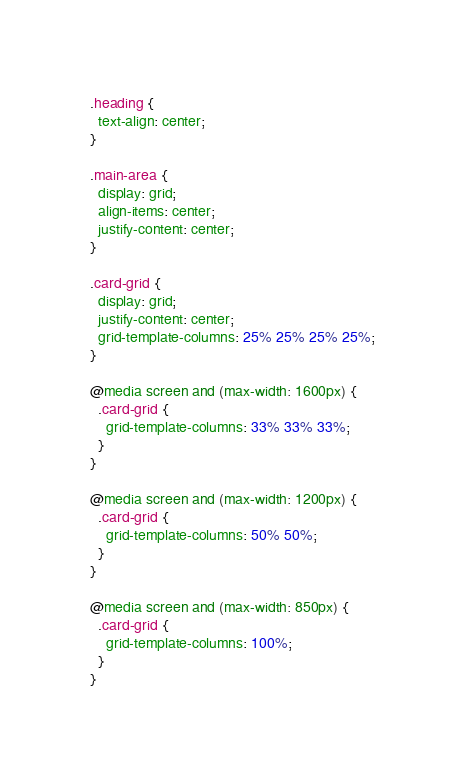Convert code to text. <code><loc_0><loc_0><loc_500><loc_500><_CSS_>.heading {
  text-align: center;
}

.main-area {
  display: grid;
  align-items: center;
  justify-content: center;
}

.card-grid {
  display: grid;
  justify-content: center;
  grid-template-columns: 25% 25% 25% 25%;
}

@media screen and (max-width: 1600px) {
  .card-grid {
    grid-template-columns: 33% 33% 33%;
  }
}

@media screen and (max-width: 1200px) {
  .card-grid {
    grid-template-columns: 50% 50%;
  }
}

@media screen and (max-width: 850px) {
  .card-grid {
    grid-template-columns: 100%;
  }
}
</code> 